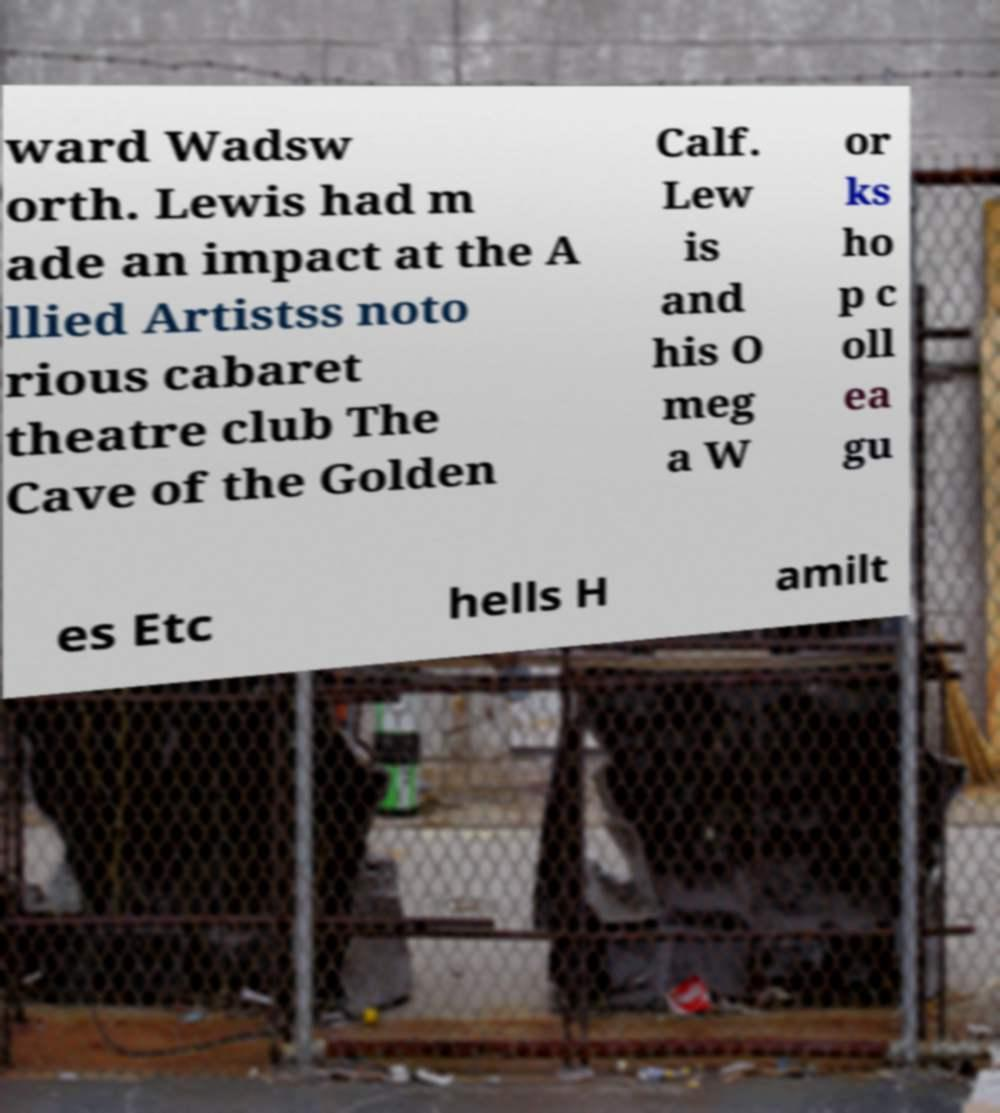Could you extract and type out the text from this image? ward Wadsw orth. Lewis had m ade an impact at the A llied Artistss noto rious cabaret theatre club The Cave of the Golden Calf. Lew is and his O meg a W or ks ho p c oll ea gu es Etc hells H amilt 